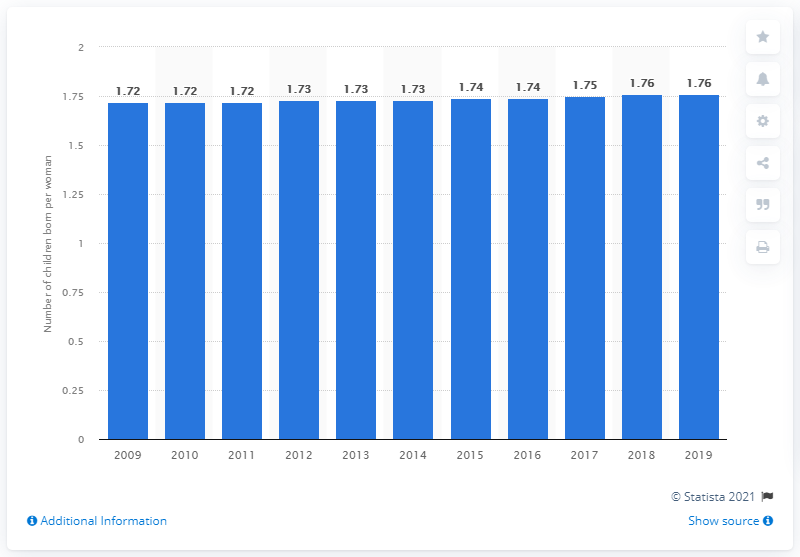Give some essential details in this illustration. The fertility rate in Armenia was 1.76 in 2019. 